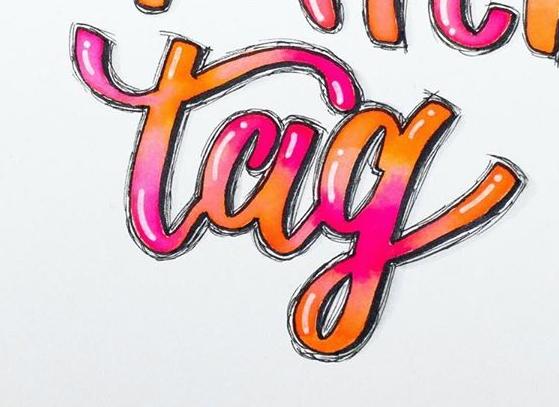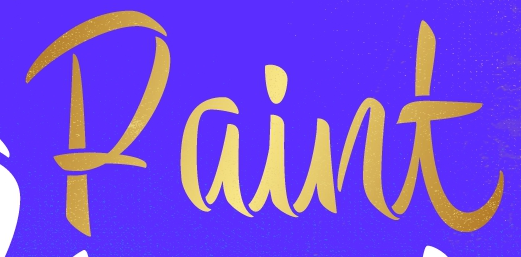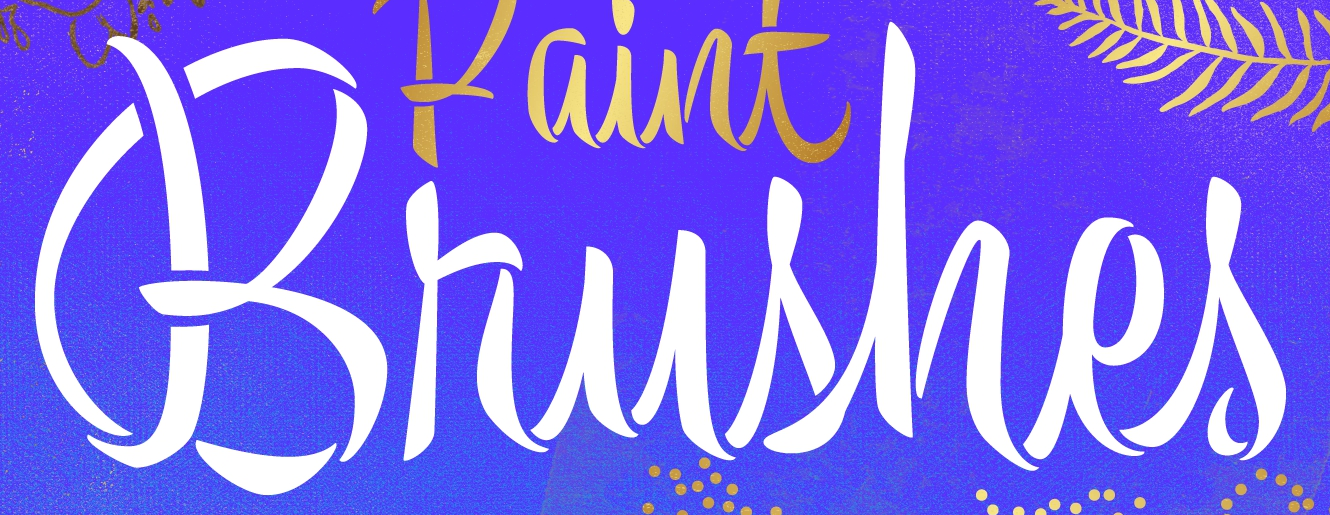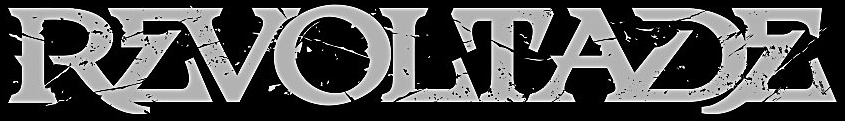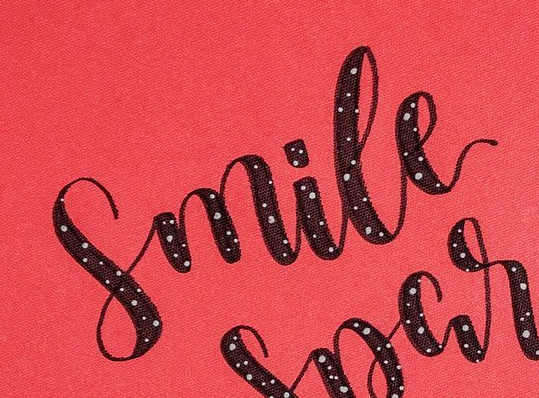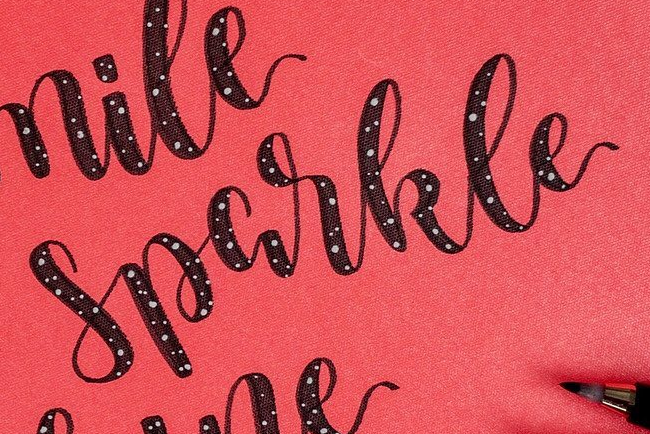Read the text from these images in sequence, separated by a semicolon. tag; Paint; Brushes; REVOLTADE; Smile; Sparkle 